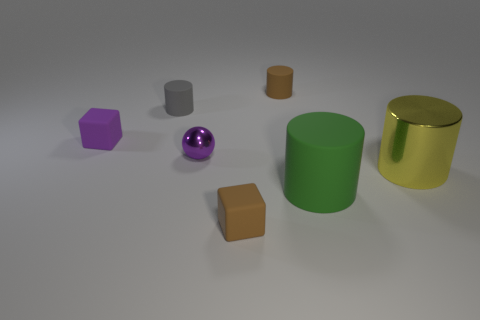Add 3 purple metal cylinders. How many objects exist? 10 Subtract all cubes. How many objects are left? 5 Subtract 0 cyan cylinders. How many objects are left? 7 Subtract all purple spheres. Subtract all small purple rubber blocks. How many objects are left? 5 Add 6 purple balls. How many purple balls are left? 7 Add 1 rubber things. How many rubber things exist? 6 